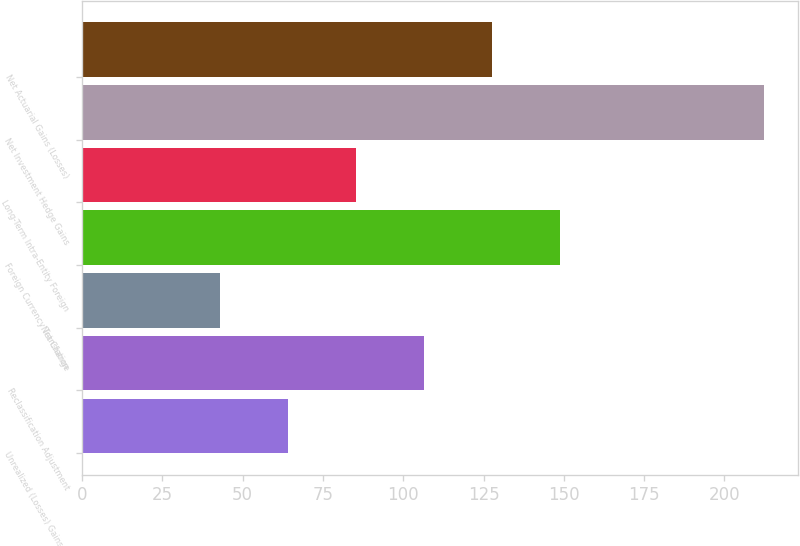Convert chart. <chart><loc_0><loc_0><loc_500><loc_500><bar_chart><fcel>Unrealized (Losses) Gains on<fcel>Reclassification Adjustment<fcel>Net Change<fcel>Foreign Currency Translation<fcel>Long-Term Intra-Entity Foreign<fcel>Net Investment Hedge Gains<fcel>Net Actuarial Gains (Losses)<nl><fcel>64.07<fcel>106.45<fcel>42.88<fcel>148.83<fcel>85.26<fcel>212.4<fcel>127.64<nl></chart> 